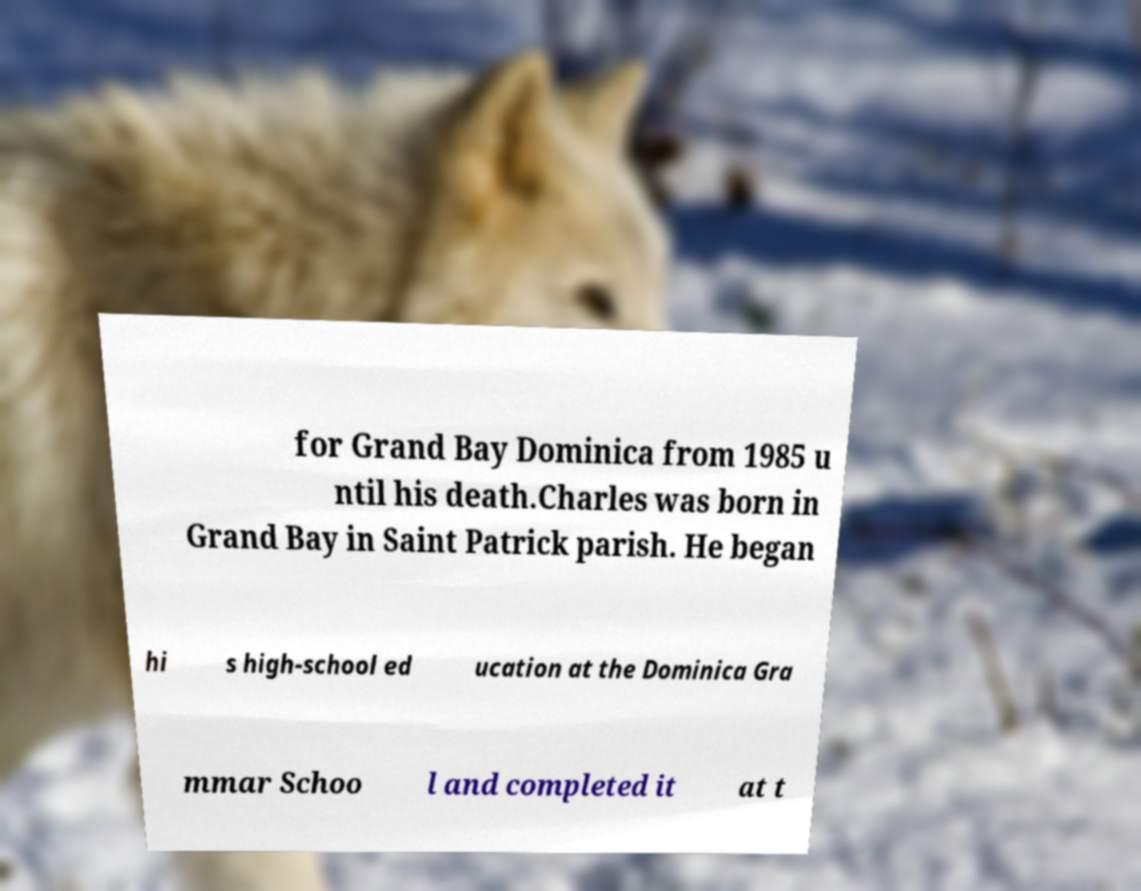Please read and relay the text visible in this image. What does it say? for Grand Bay Dominica from 1985 u ntil his death.Charles was born in Grand Bay in Saint Patrick parish. He began hi s high-school ed ucation at the Dominica Gra mmar Schoo l and completed it at t 